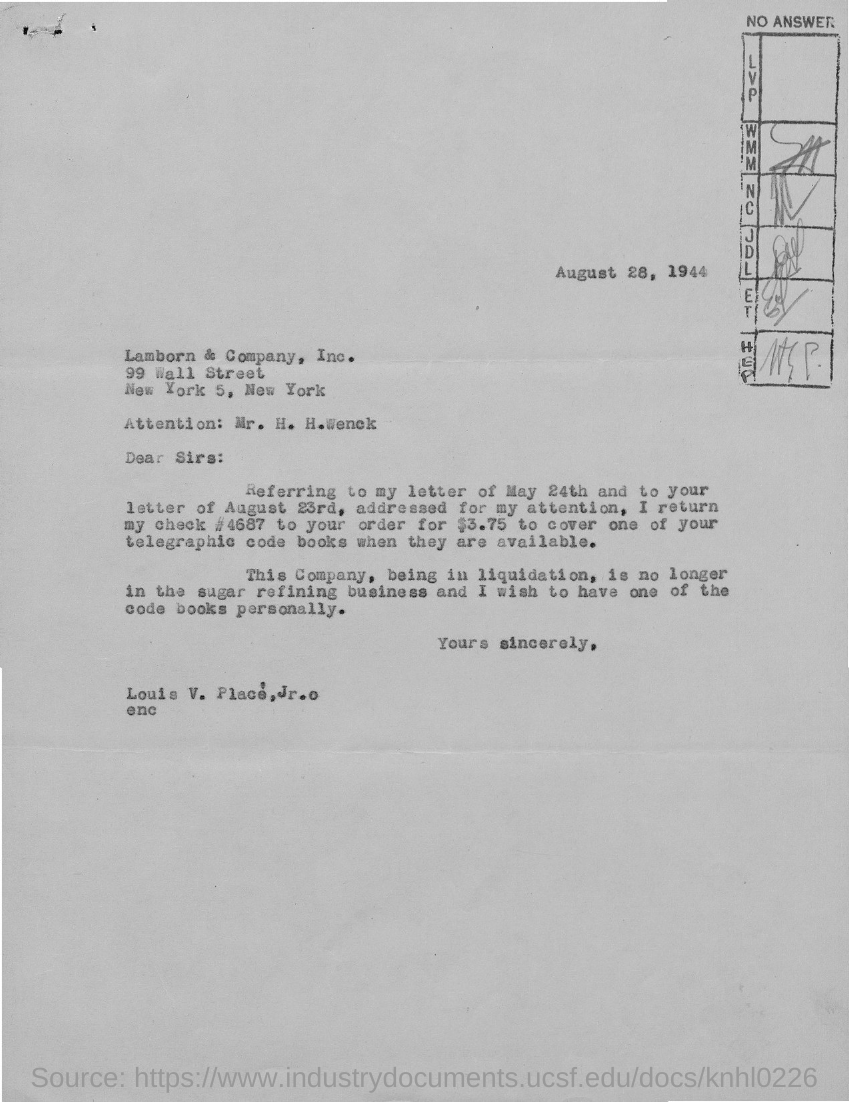Which company the letter is addressed to?
Provide a short and direct response. Lamborn & Company, Inc. What is the date on the letter?
Provide a succinct answer. August 28, 1944. Who is the sender of the letter?
Keep it short and to the point. Louis V. What is the check number that is returned by Louis V. Palace?
Ensure brevity in your answer.  # 4687. 